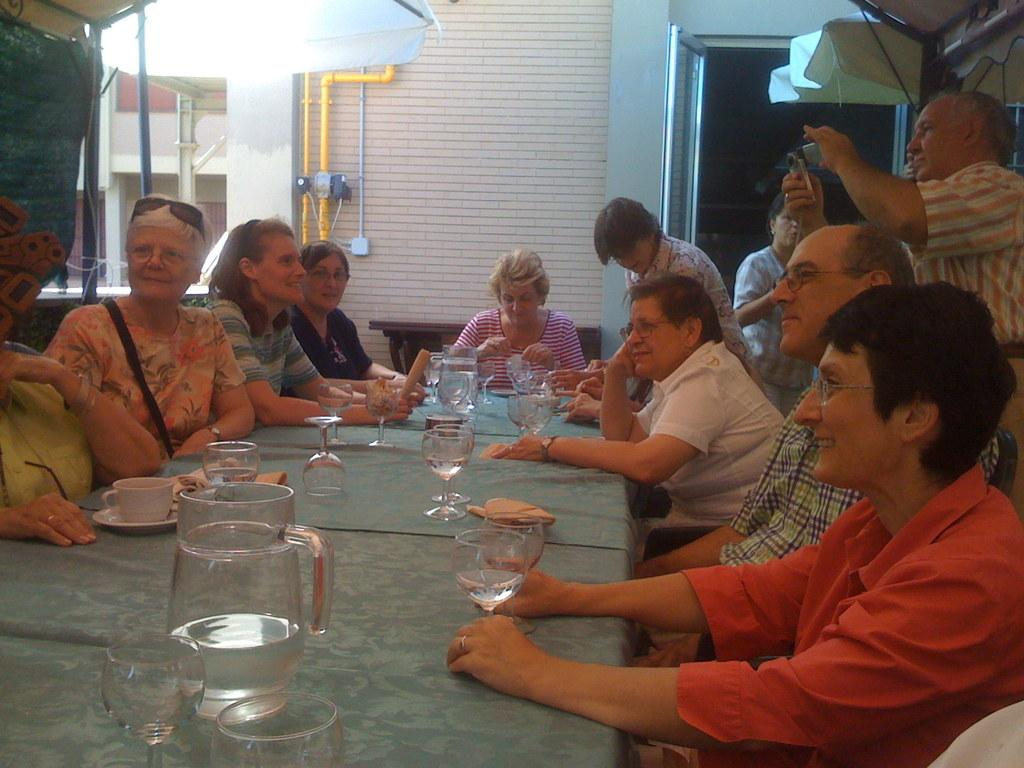What are the people in the image doing? There are people sitting on chairs and standing in the image. Can you describe the man holding an object in the image? A man is holding a camera in the image. What types of objects can be seen on the table in the image? There are glasses, jars, a cup, and a saucer on the table in the image. What can be seen in the background of the image? There is a wall and a door in the background of the image. What type of owl can be seen perched on the door in the image? There is no owl present in the image; it only features people, a man holding a camera, objects on a table, and a wall and door in the background. 